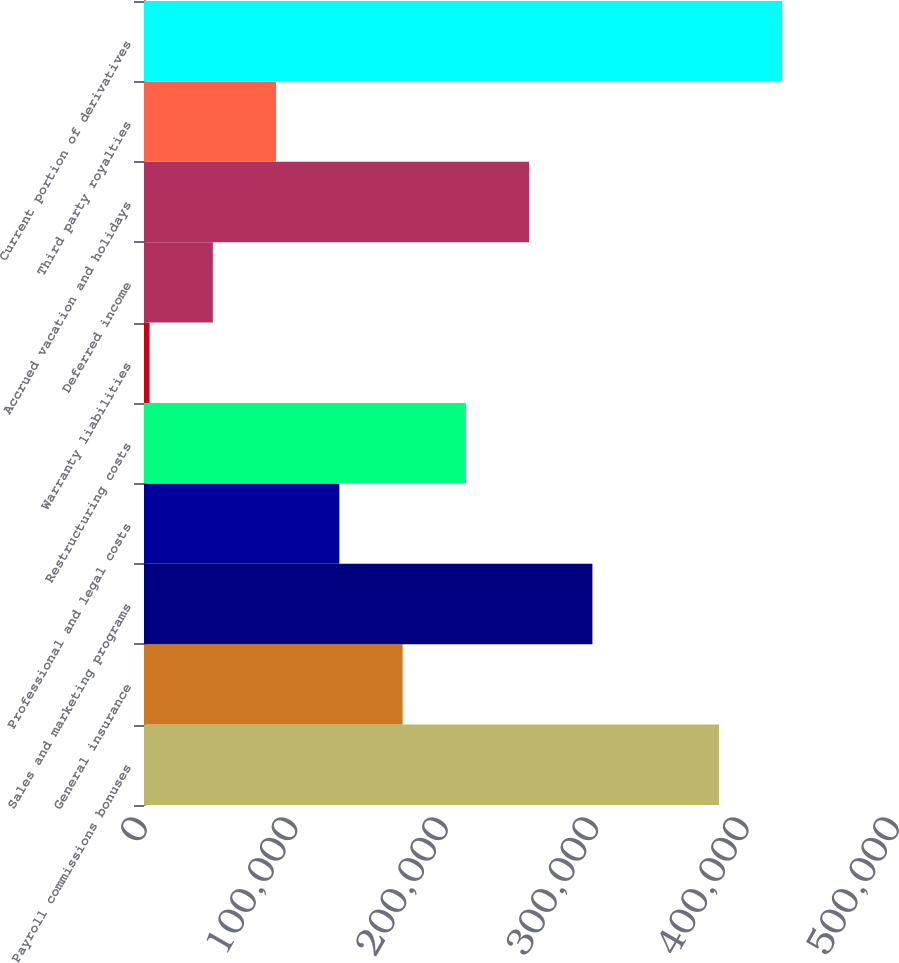Convert chart to OTSL. <chart><loc_0><loc_0><loc_500><loc_500><bar_chart><fcel>Payroll commissions bonuses<fcel>General insurance<fcel>Sales and marketing programs<fcel>Professional and legal costs<fcel>Restructuring costs<fcel>Warranty liabilities<fcel>Deferred income<fcel>Accrued vacation and holidays<fcel>Third party royalties<fcel>Current portion of derivatives<nl><fcel>382272<fcel>171950<fcel>298143<fcel>129886<fcel>214014<fcel>3693<fcel>45757.3<fcel>256079<fcel>87821.6<fcel>424336<nl></chart> 